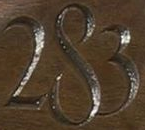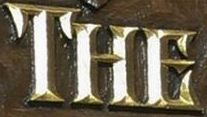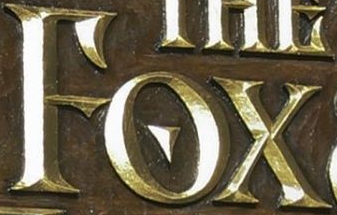Identify the words shown in these images in order, separated by a semicolon. 283; THE; FOX 